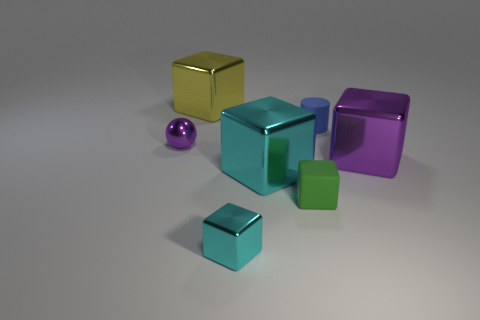There is a purple metal object in front of the purple shiny sphere; does it have the same size as the blue matte cylinder?
Ensure brevity in your answer.  No. There is another small object that is the same shape as the small cyan metal thing; what is its color?
Offer a very short reply. Green. Is there anything else that is the same shape as the big yellow metal object?
Your answer should be compact. Yes. The small shiny thing that is behind the small cyan metallic block has what shape?
Make the answer very short. Sphere. How many other rubber things have the same shape as the small cyan object?
Ensure brevity in your answer.  1. There is a rubber thing that is in front of the large cyan metallic cube; is its color the same as the small shiny thing in front of the small metallic sphere?
Ensure brevity in your answer.  No. What number of objects are small cyan matte things or yellow metal cubes?
Provide a short and direct response. 1. What number of big purple cubes are the same material as the small purple object?
Your answer should be compact. 1. Are there fewer tiny matte objects than red rubber cubes?
Your answer should be compact. No. Do the tiny thing that is right of the small rubber cube and the tiny purple object have the same material?
Offer a very short reply. No. 